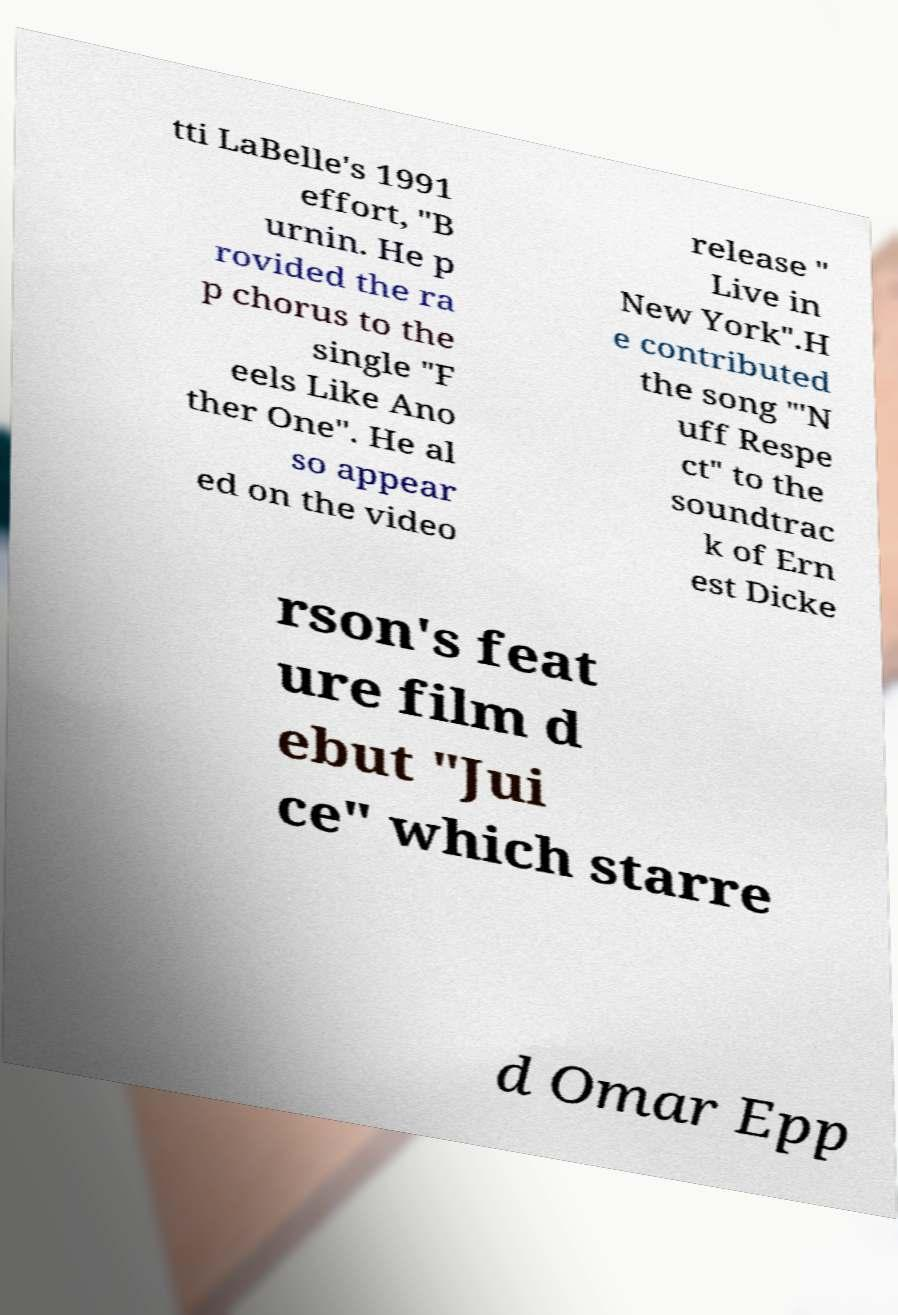Could you assist in decoding the text presented in this image and type it out clearly? tti LaBelle's 1991 effort, "B urnin. He p rovided the ra p chorus to the single "F eels Like Ano ther One". He al so appear ed on the video release " Live in New York".H e contributed the song "'N uff Respe ct" to the soundtrac k of Ern est Dicke rson's feat ure film d ebut "Jui ce" which starre d Omar Epp 